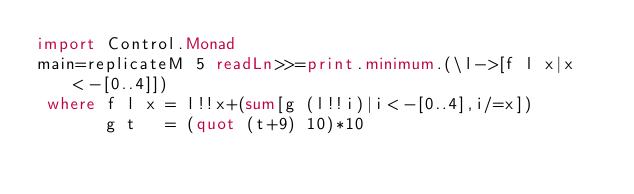<code> <loc_0><loc_0><loc_500><loc_500><_Haskell_>import Control.Monad
main=replicateM 5 readLn>>=print.minimum.(\l->[f l x|x<-[0..4]])
 where f l x = l!!x+(sum[g (l!!i)|i<-[0..4],i/=x])
       g t   = (quot (t+9) 10)*10</code> 